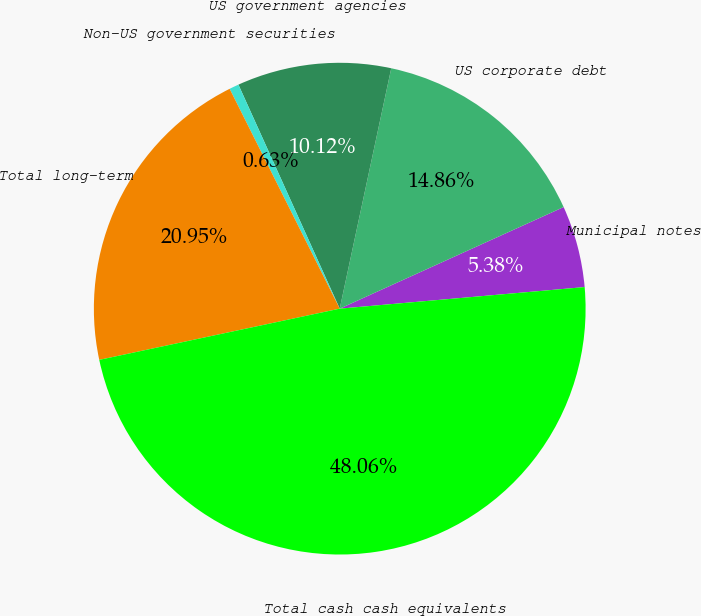Convert chart. <chart><loc_0><loc_0><loc_500><loc_500><pie_chart><fcel>Municipal notes<fcel>US corporate debt<fcel>US government agencies<fcel>Non-US government securities<fcel>Total long-term<fcel>Total cash cash equivalents<nl><fcel>5.38%<fcel>14.86%<fcel>10.12%<fcel>0.63%<fcel>20.95%<fcel>48.06%<nl></chart> 